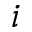Convert formula to latex. <formula><loc_0><loc_0><loc_500><loc_500>i</formula> 